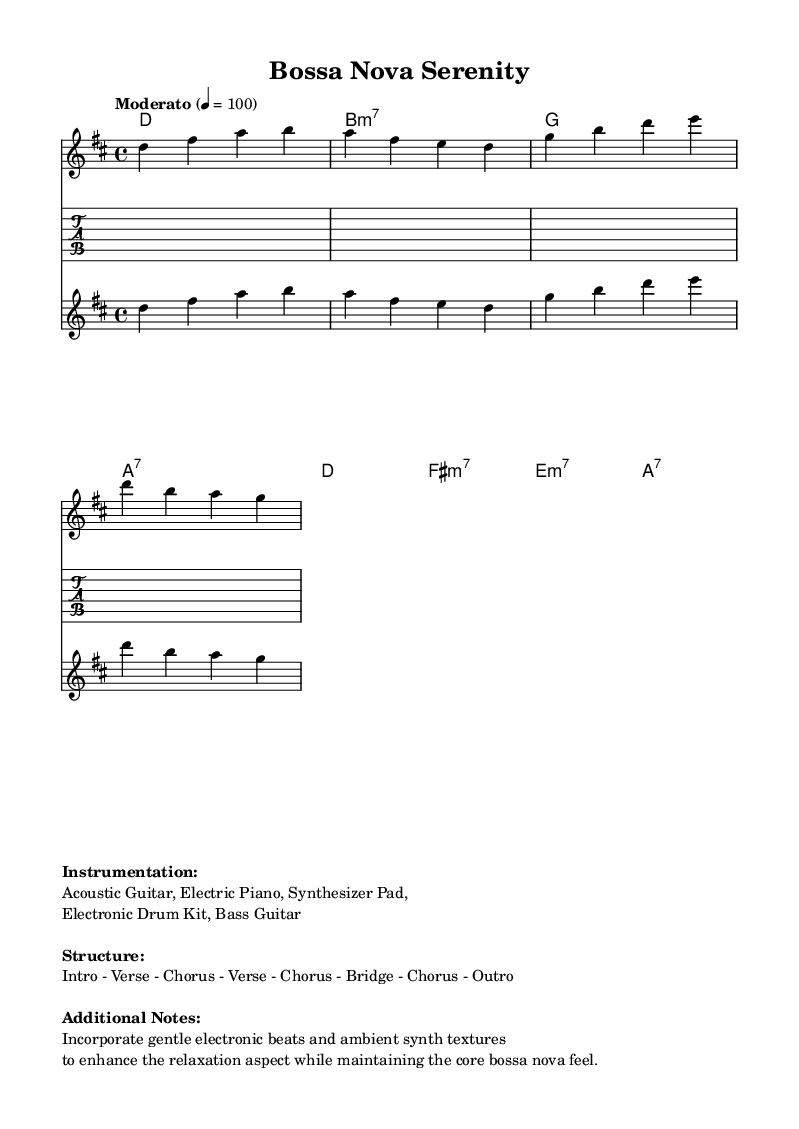What is the key signature of this music? The key signature indicates the notes that are sharp or flat throughout the piece. Here, it is indicated by the presence of two sharps (F# and C#). Therefore, the key signature is D major.
Answer: D major What is the time signature of this music? The time signature is shown at the beginning of the score and is represented by two numbers stacked on each other. In this score, the time signature is 4/4, which means there are four beats in each measure.
Answer: 4/4 What is the tempo marking for this piece? The tempo marking indicates the speed of the music. It is presented in beats per minute. Here, it states "Moderato" and a metronome marking of 100, meaning it should be played at a moderate pace.
Answer: Moderato How many measures are in the melody section? To find the number of measures, count the vertical bar lines that separate each measure. In the provided melody, there are a total of 8 measures.
Answer: 8 What are the main instruments indicated in the piece? The instrumentation is noted in the markup at the end of the score. It lists the instruments required for the performance of the piece. The main instruments are Acoustic Guitar, Electric Piano, Synthesizer Pad, Electronic Drum Kit, and Bass Guitar.
Answer: Acoustic Guitar, Electric Piano, Synthesizer Pad, Electronic Drum Kit, Bass Guitar What sections does this piece consist of? The structure of the piece is detailed in the markup section. By looking at this, we see that it has an Intro, Verses, Chorus, Bridge, and Outro, indicating how the music is organized.
Answer: Intro - Verse - Chorus - Verse - Chorus - Bridge - Chorus - Outro What type of chords are present in the harmonies section? The chord types can be inferred from the chord names presented. In this case, we see major chords (D and A), minor chords (B minor and F# minor), and seventh chords (A7). Therefore, the piece incorporates both major and minor chords along with seventh chords.
Answer: Major and Minor chords, Seventh chords 